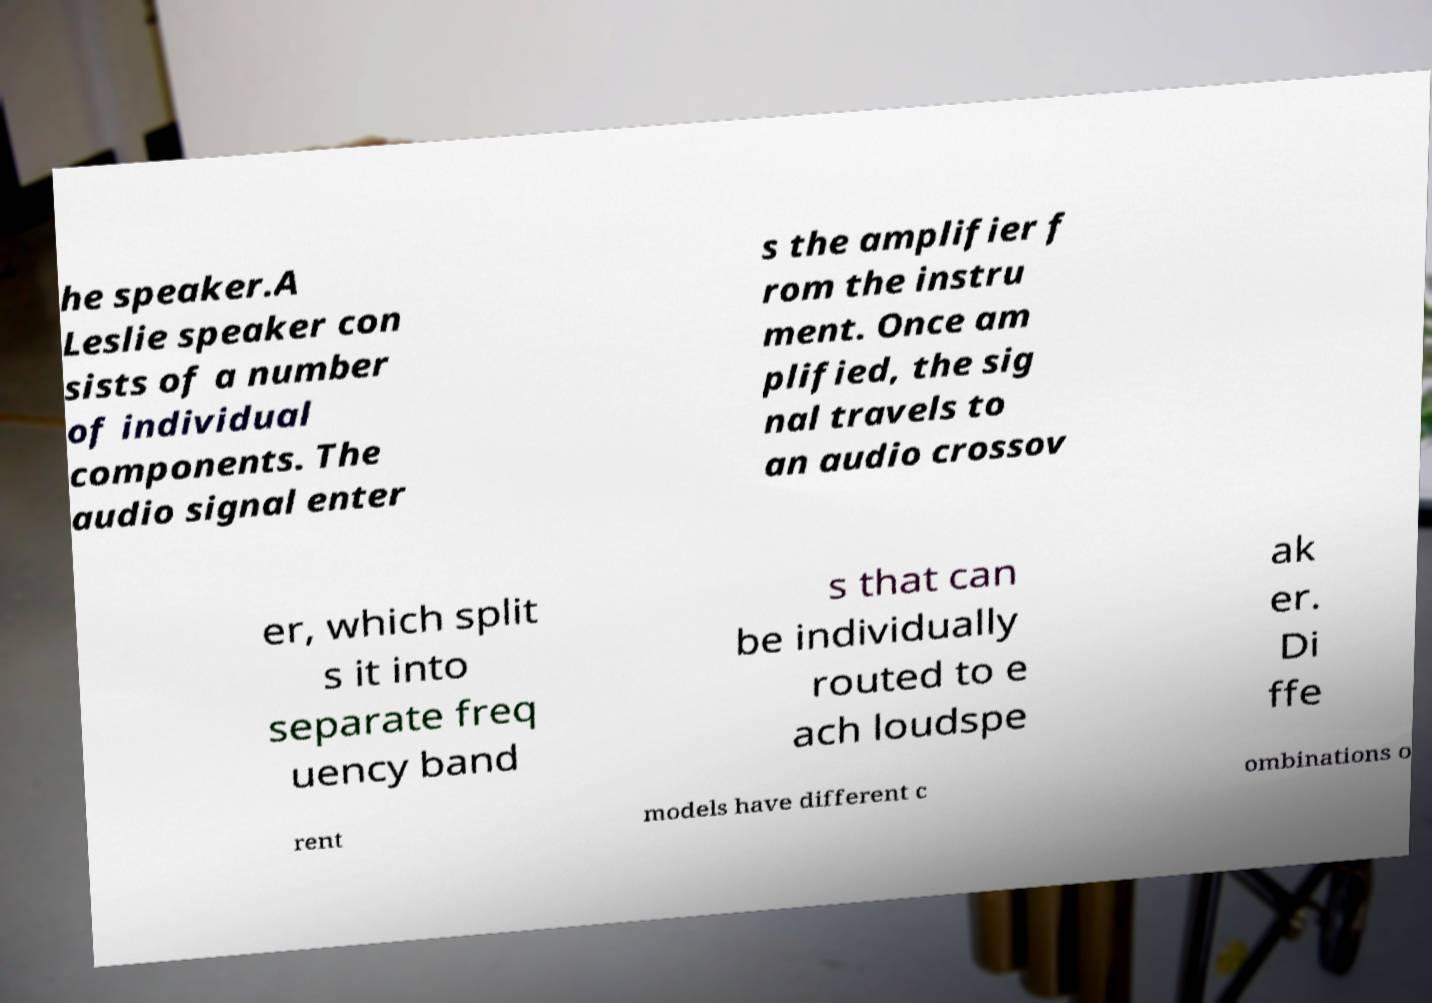Can you accurately transcribe the text from the provided image for me? he speaker.A Leslie speaker con sists of a number of individual components. The audio signal enter s the amplifier f rom the instru ment. Once am plified, the sig nal travels to an audio crossov er, which split s it into separate freq uency band s that can be individually routed to e ach loudspe ak er. Di ffe rent models have different c ombinations o 